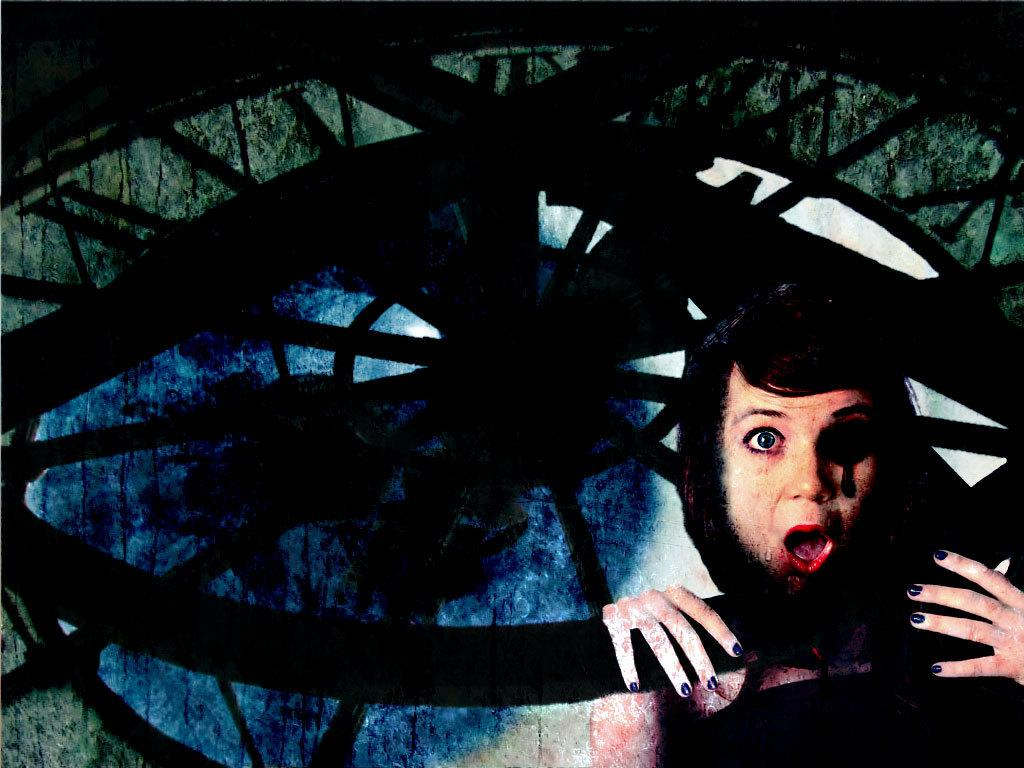Who is present in the image? There is a woman in the image. What is the woman's position in relation to the window? The woman is standing behind a window. What type of artwork is the image? The image appears to be a painting. What color is the beef in the image? There is no beef present in the image; it features a woman standing behind a window in a painting. 